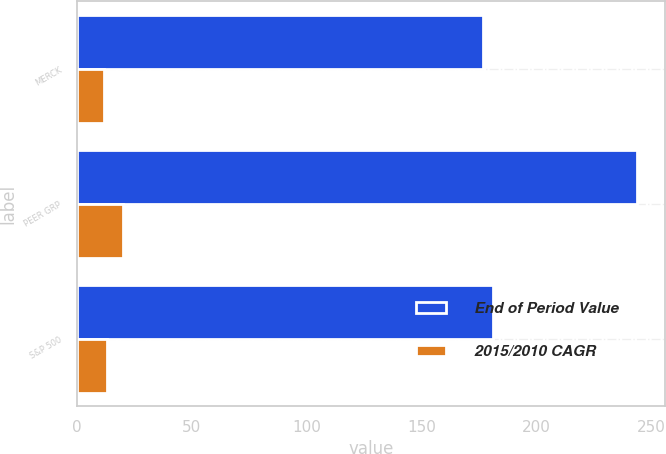Convert chart. <chart><loc_0><loc_0><loc_500><loc_500><stacked_bar_chart><ecel><fcel>MERCK<fcel>PEER GRP<fcel>S&P 500<nl><fcel>End of Period Value<fcel>177<fcel>244<fcel>181<nl><fcel>2015/2010 CAGR<fcel>12<fcel>20<fcel>13<nl></chart> 